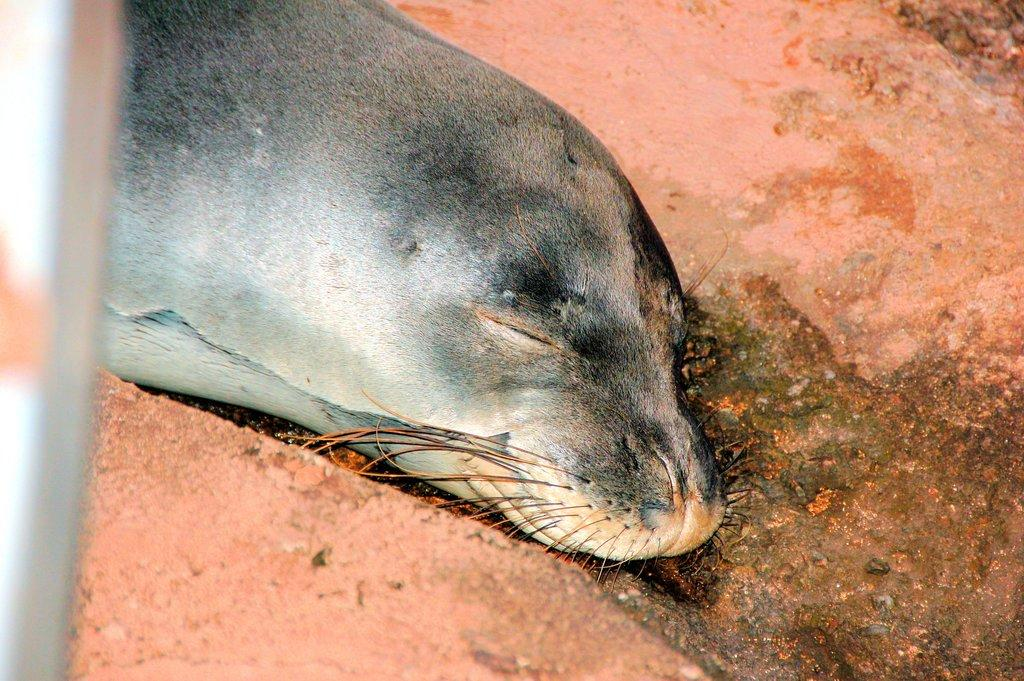What type of animal can be seen in the image? There is an animal in the image, but the specific type of animal cannot be determined from the provided facts. What is the animal doing in the image? The animal has closed its eyes in the image. What is the position of the animal in the image? The animal is lying on a surface in the image. What color is the object in the image? There is a gray color object in the image. What is the color of the background in the image? The background of the image is pink. How many trucks are visible in the image? There are no trucks present in the image. What type of cracker is the animal holding in the image? There is no cracker present in the image, and the animal is not holding anything. 